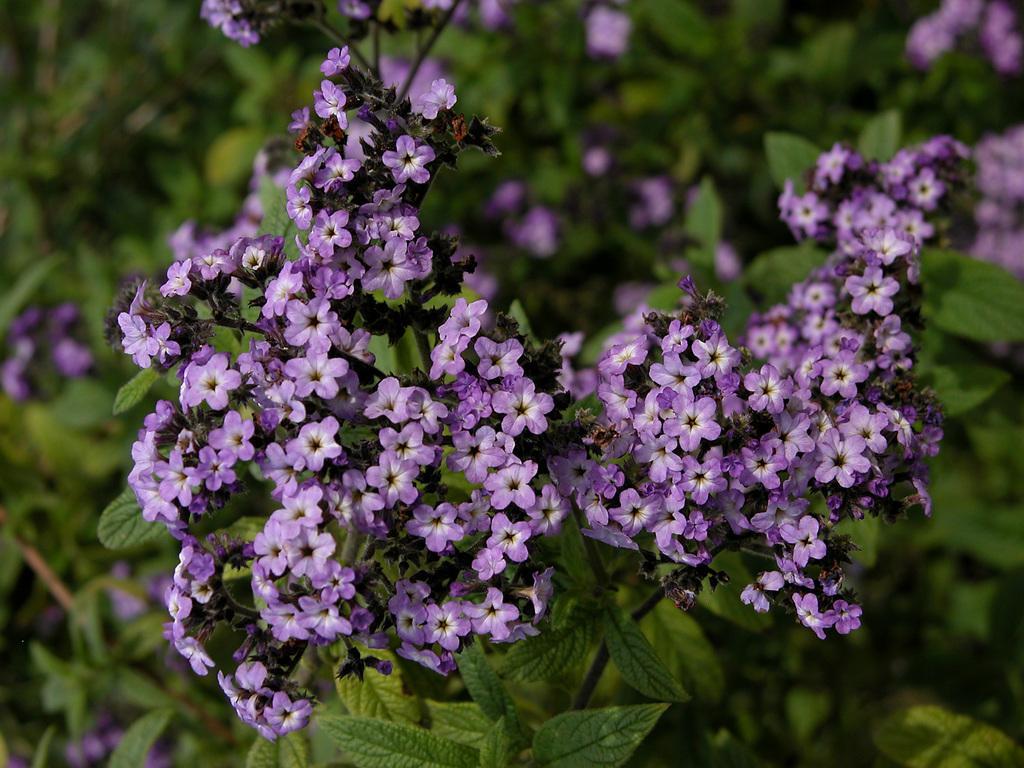In one or two sentences, can you explain what this image depicts? In this image I can see few purple color flowers and few green leaves. Background is blurred. 